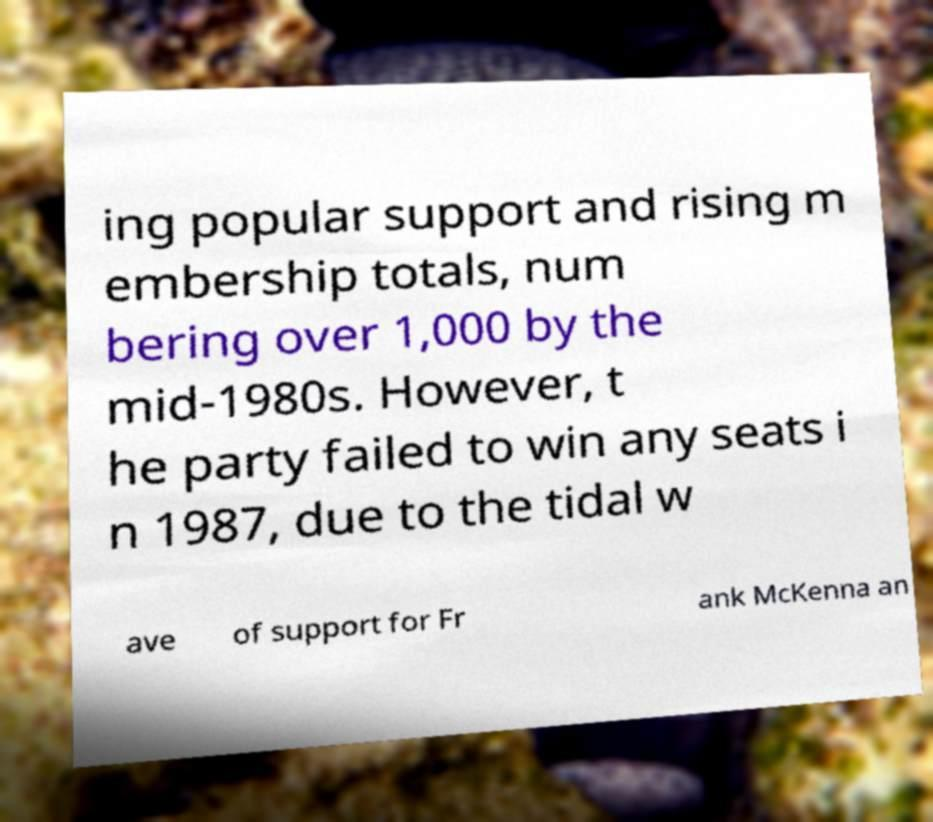For documentation purposes, I need the text within this image transcribed. Could you provide that? ing popular support and rising m embership totals, num bering over 1,000 by the mid-1980s. However, t he party failed to win any seats i n 1987, due to the tidal w ave of support for Fr ank McKenna an 